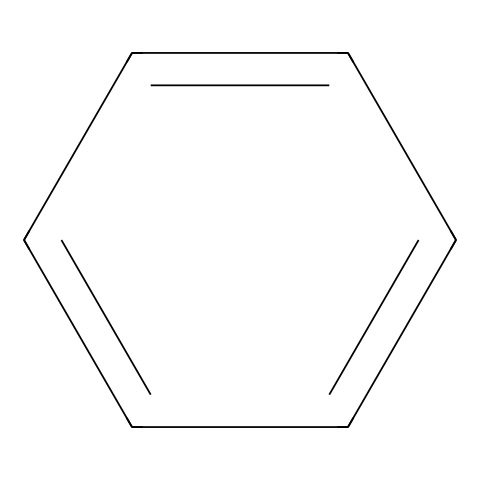What is the molecular formula of this compound? The compound represented by the SMILES notation c1ccccc1 is benzene. Benzene has six carbon atoms and six hydrogen atoms, giving it the molecular formula C6H6.
Answer: C6H6 How many carbon atoms are present in the structure? By analyzing the SMILES c1ccccc1, we can count the 'c' symbols, which represent carbon atoms. There are six 'c' symbols in total, indicating that there are six carbon atoms in benzene.
Answer: six What type of hybridization do the carbon atoms in benzene undergo? In benzene, each carbon atom is sp2 hybridized due to the formation of one sigma bond with a neighboring carbon and one sigma bond with a hydrogen atom. The remaining p orbital forms a delocalized pi bond system, characteristic of aromatic compounds.
Answer: sp2 What type of compound is benzene classified as? Benzene, with its cyclic structure and alternating double bonds, is classified as an aromatic hydrocarbon. This classification is due to its stability and adherence to Huckel's rule (4n + 2 π electrons, where n = 1 in this case).
Answer: aromatic hydrocarbon How many hydrogen atoms are attached to the benzene ring? Each of the six carbon atoms in benzene is bonded to one hydrogen atom, resulting in a total of six hydrogen atoms being attached to the benzene ring as indicated by the molecular formula C6H6.
Answer: six What characteristic feature does benzene's structure exhibit? Benzene exhibits resonance, which means that the electrons in the double bonds are delocalized across the carbon ring. This gives benzene its unique stability and is represented by the alternating double bonds in its structure.
Answer: resonance 